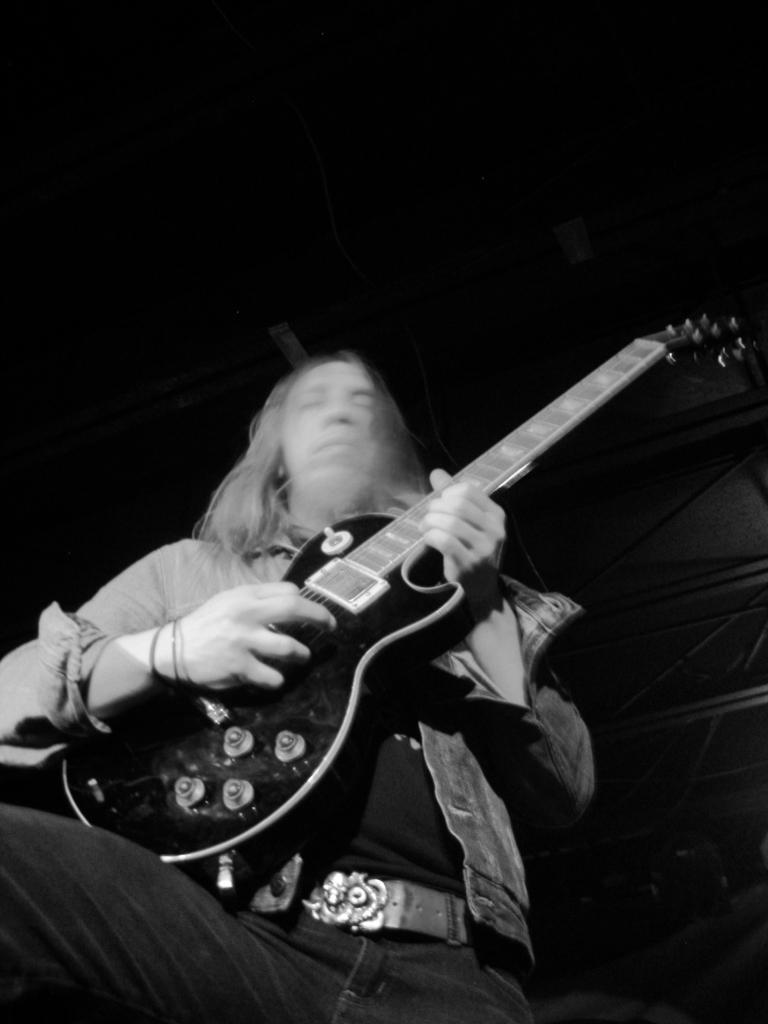What is the main subject of the image? The main subject of the image is a man. What is the man holding in the image? The man is holding a guitar in the image. What is the man doing with the guitar? The man is playing the guitar in the image. What type of lipstick is the man wearing in the image? There is no lipstick or any indication of makeup on the man in the image. How many beans are visible on the man's guitar in the image? There are no beans present in the image, and the guitar does not have any beans on it. 